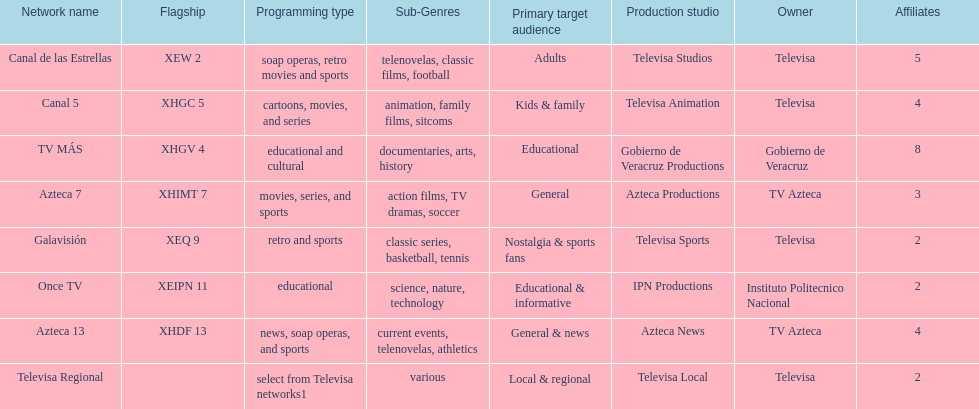Who has the most number of affiliates? TV MÁS. Can you give me this table as a dict? {'header': ['Network name', 'Flagship', 'Programming type', 'Sub-Genres', 'Primary target audience', 'Production studio', 'Owner', 'Affiliates'], 'rows': [['Canal de las Estrellas', 'XEW 2', 'soap operas, retro movies and sports', 'telenovelas, classic films, football', 'Adults', 'Televisa Studios', 'Televisa', '5'], ['Canal 5', 'XHGC 5', 'cartoons, movies, and series', 'animation, family films, sitcoms', 'Kids & family', 'Televisa Animation', 'Televisa', '4'], ['TV MÁS', 'XHGV 4', 'educational and cultural', 'documentaries, arts, history', 'Educational', 'Gobierno de Veracruz Productions', 'Gobierno de Veracruz', '8'], ['Azteca 7', 'XHIMT 7', 'movies, series, and sports', 'action films, TV dramas, soccer', 'General', 'Azteca Productions', 'TV Azteca', '3'], ['Galavisión', 'XEQ 9', 'retro and sports', 'classic series, basketball, tennis', 'Nostalgia & sports fans', 'Televisa Sports', 'Televisa', '2'], ['Once TV', 'XEIPN 11', 'educational', 'science, nature, technology', 'Educational & informative', 'IPN Productions', 'Instituto Politecnico Nacional', '2'], ['Azteca 13', 'XHDF 13', 'news, soap operas, and sports', 'current events, telenovelas, athletics', 'General & news', 'Azteca News', 'TV Azteca', '4'], ['Televisa Regional', '', 'select from Televisa networks1', 'various', 'Local & regional', 'Televisa Local', 'Televisa', '2']]} 